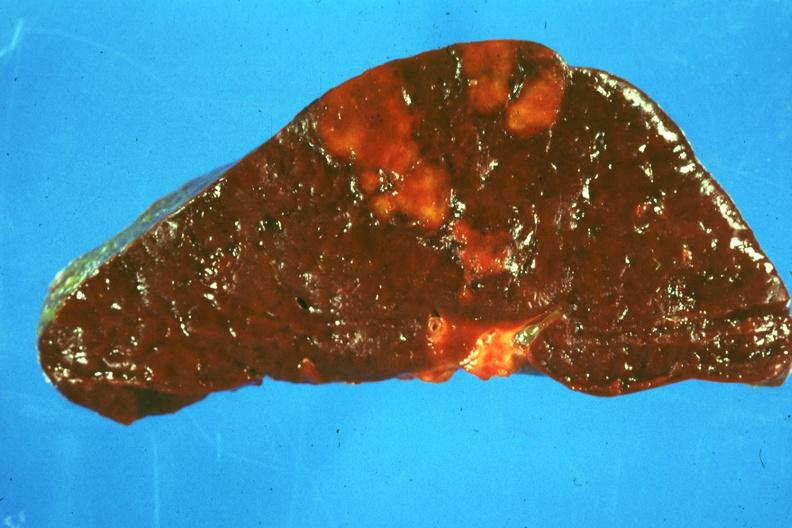s child present?
Answer the question using a single word or phrase. No 